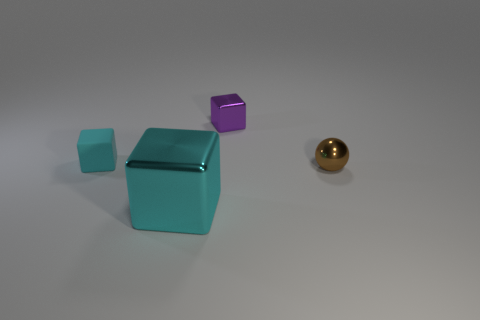What is the texture of the objects and surface in the image? The objects and the surface appear to have a matte finish with a slight sheen, suggesting they are made of a material such as metal or plastic. The teal and purple objects have a slight reflective quality, not glossy but with enough luster to reflect some of the light, whereas the small metal ball looks to have a polished, smoother finish that reflects the light more clearly. 